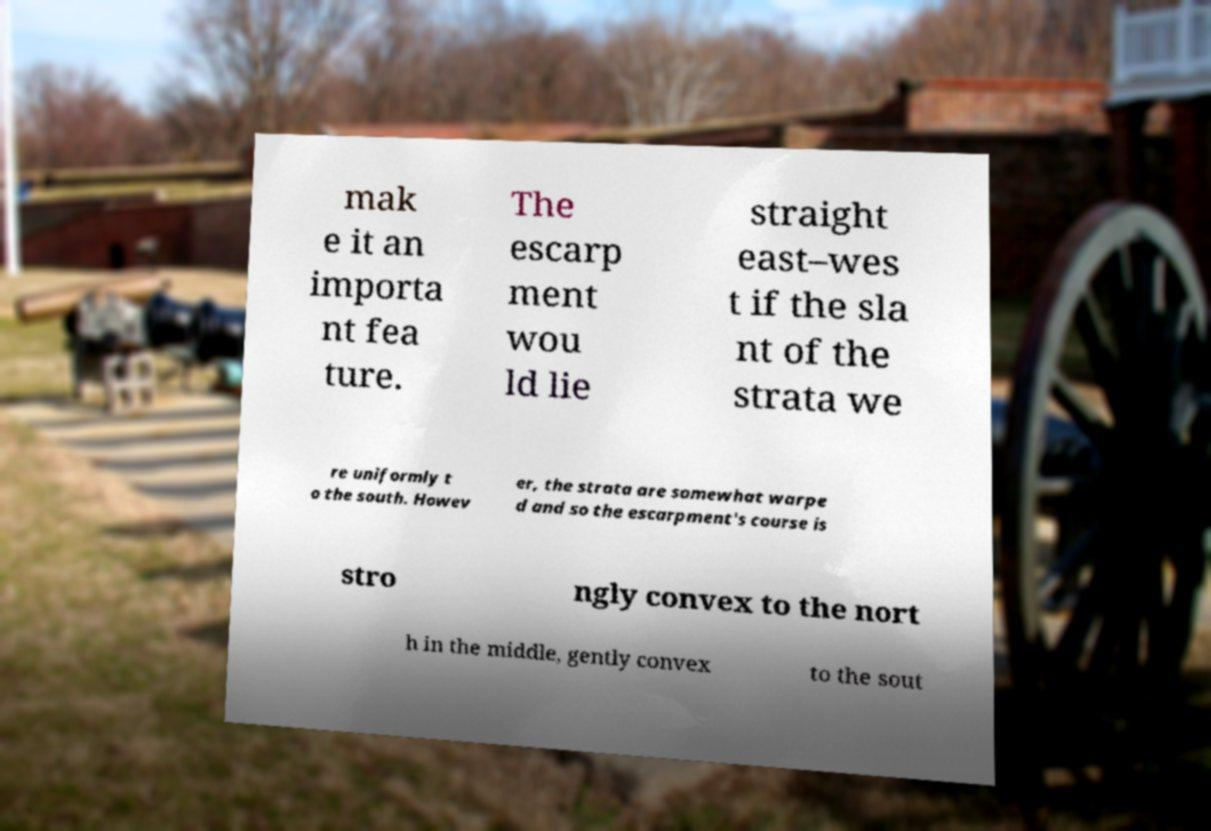Please read and relay the text visible in this image. What does it say? mak e it an importa nt fea ture. The escarp ment wou ld lie straight east–wes t if the sla nt of the strata we re uniformly t o the south. Howev er, the strata are somewhat warpe d and so the escarpment's course is stro ngly convex to the nort h in the middle, gently convex to the sout 